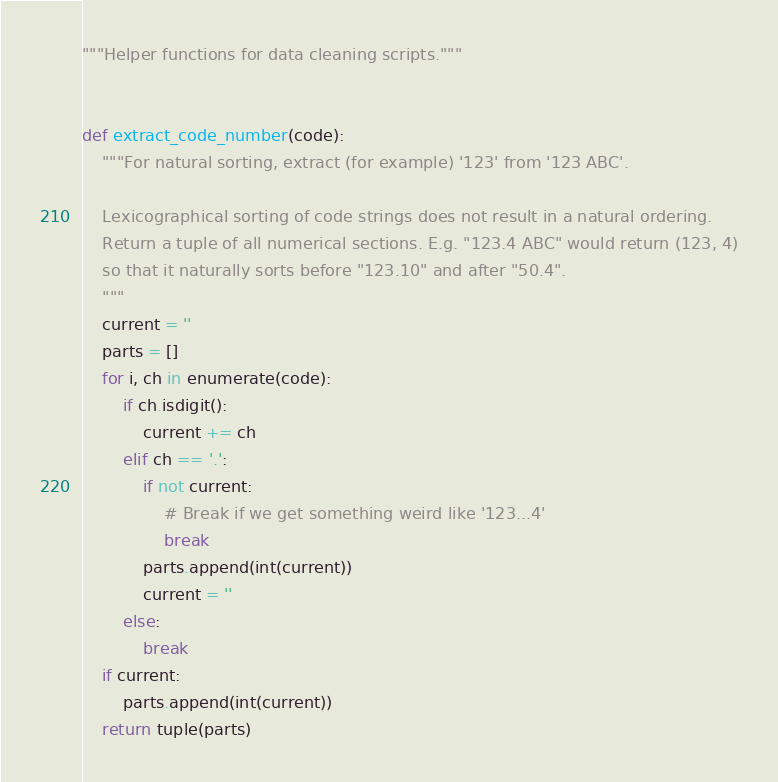<code> <loc_0><loc_0><loc_500><loc_500><_Python_>"""Helper functions for data cleaning scripts."""


def extract_code_number(code):
    """For natural sorting, extract (for example) '123' from '123 ABC'.

    Lexicographical sorting of code strings does not result in a natural ordering.
    Return a tuple of all numerical sections. E.g. "123.4 ABC" would return (123, 4)
    so that it naturally sorts before "123.10" and after "50.4".
    """
    current = ''
    parts = []
    for i, ch in enumerate(code):
        if ch.isdigit():
            current += ch
        elif ch == '.':
            if not current:
                # Break if we get something weird like '123...4'
                break
            parts.append(int(current))
            current = ''
        else:
            break
    if current:
        parts.append(int(current))
    return tuple(parts)
</code> 